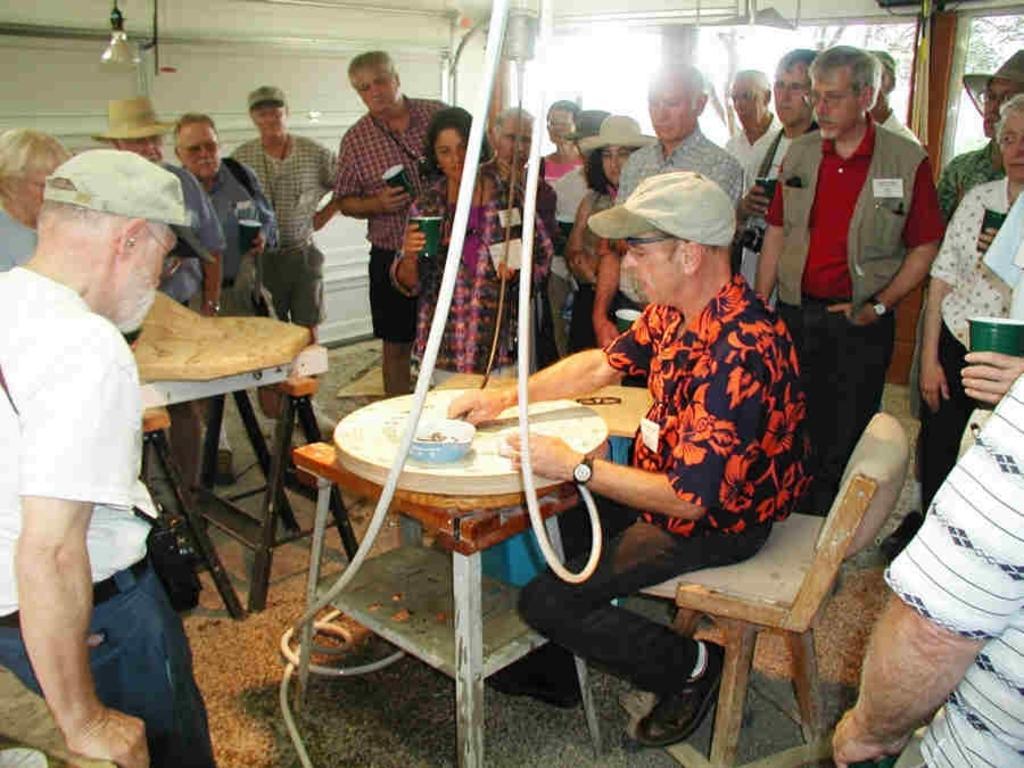Can you describe this image briefly? This picture shows a group of people standing and a man seated on a chair and he holds a bowl in his hand 